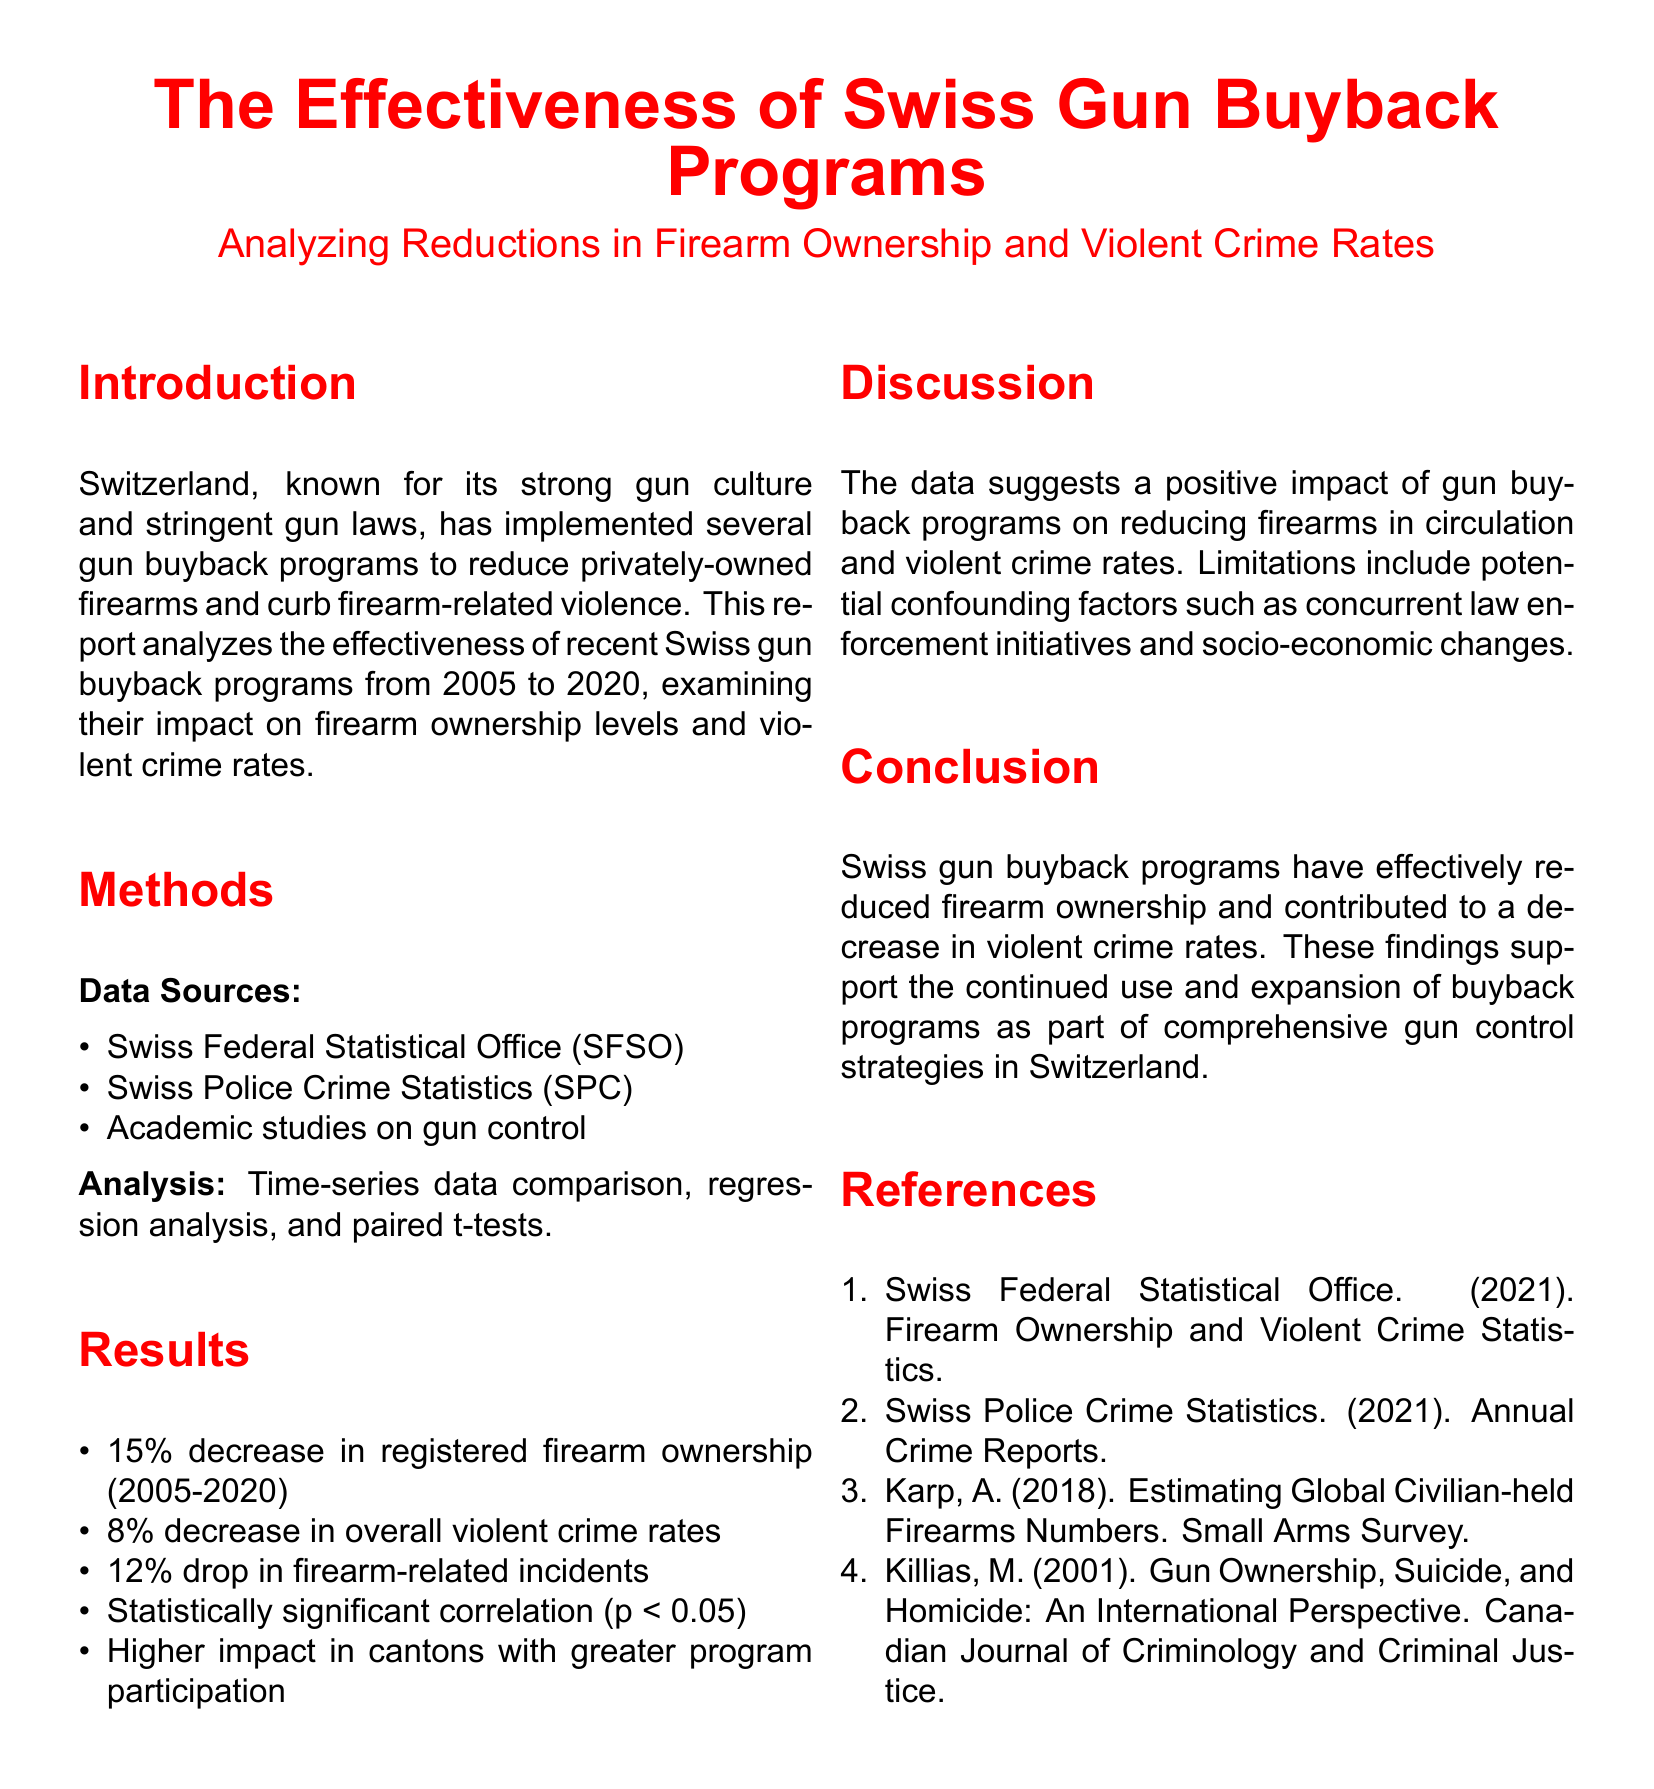What is the percentage decrease in registered firearm ownership from 2005 to 2020? The report states there was a 15% decrease in registered firearm ownership from 2005 to 2020.
Answer: 15% What is the overall percentage decrease in violent crime rates? The report indicates an 8% decrease in overall violent crime rates.
Answer: 8% What is the drop in firearm-related incidents reported? The reduction in firearm-related incidents is noted as 12%.
Answer: 12% Which source provides firearm ownership statistics? The source that provides firearm ownership statistics is the Swiss Federal Statistical Office (SFSO).
Answer: Swiss Federal Statistical Office What does p < 0.05 indicate regarding the study's findings? The p < 0.05 indicates a statistically significant correlation in the study's findings.
Answer: Statistically significant Which program has a higher impact on the results? The program with a higher impact is characterized by greater participation in the cantons.
Answer: Greater program participation What type of analysis methods were used in the study? The study employed time-series data comparison, regression analysis, and paired t-tests as methods of analysis.
Answer: Time-series data comparison, regression analysis, paired t-tests What is the primary conclusion of the report? The primary conclusion of the report is that Swiss gun buyback programs have effectively reduced firearm ownership and contributed to a decrease in violent crime rates.
Answer: Effectively reduced firearm ownership and contributed to a decrease in violent crime rates What does the discussion section highlight as a limitation? A limitation highlighted is the potential confounding factors such as concurrent law enforcement initiatives and socio-economic changes.
Answer: Potential confounding factors What is the publication year of the data from the Swiss Police Crime Statistics? The publication year of the Swiss Police Crime Statistics is 2021.
Answer: 2021 